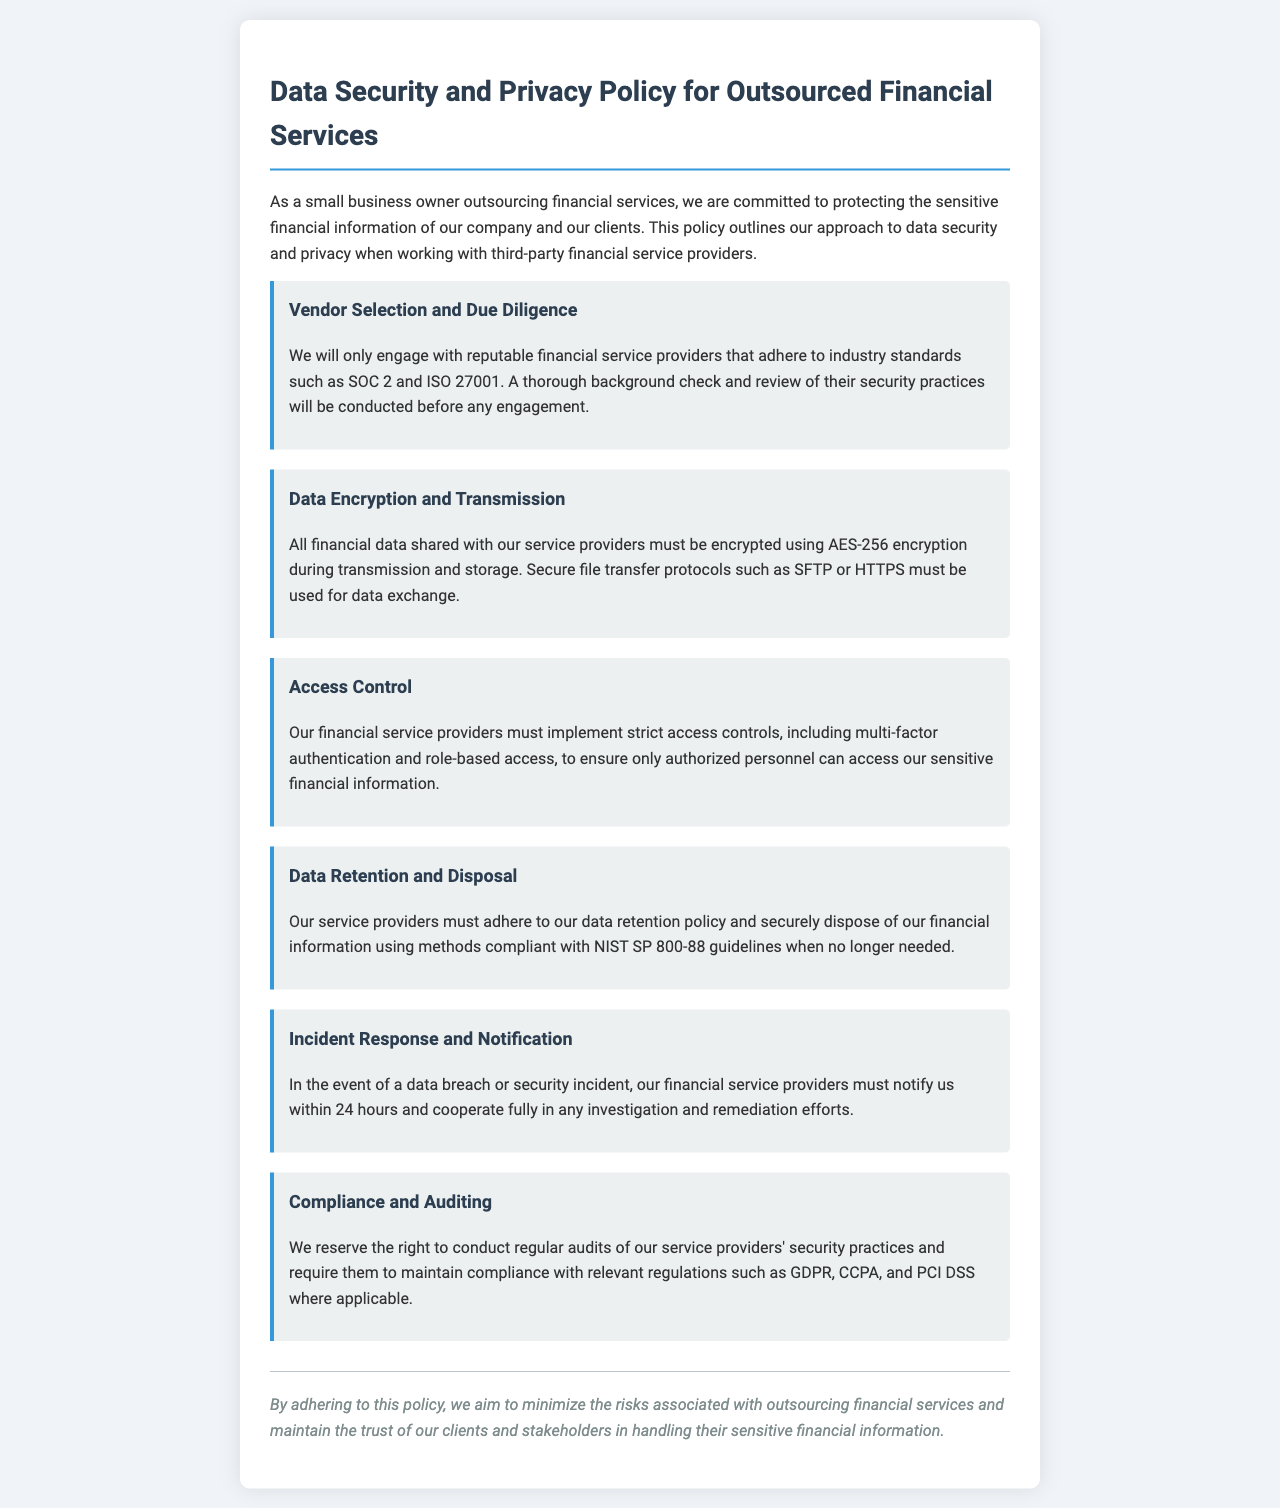What standards must vendors adhere to? The policy states that vendors must adhere to industry standards such as SOC 2 and ISO 27001.
Answer: SOC 2 and ISO 27001 What encryption method is required for financial data? The document specifies that all financial data must be encrypted using AES-256 encryption.
Answer: AES-256 What access controls must service providers implement? The policy requires service providers to implement strict access controls including multi-factor authentication and role-based access.
Answer: Multi-factor authentication and role-based access How soon must vendors notify us of a data breach? In the event of a data breach, vendors are required to notify us within 24 hours.
Answer: 24 hours Which guidelines must be followed for data disposal? The policy states that secure disposal must be compliant with NIST SP 800-88 guidelines.
Answer: NIST SP 800-88 What is the purpose of regular audits? Regular audits are conducted to ensure compliance with relevant regulations and to review security practices.
Answer: Compliance with relevant regulations What is the main goal of the policy? The main goal is to minimize risks associated with outsourcing financial services and to maintain trust with clients.
Answer: Minimize risks and maintain trust What must be done with data no longer needed? The document outlines that data no longer needed must be securely disposed of according to specific guidelines.
Answer: Securely disposed of What regulations must service providers comply with? Service providers must maintain compliance with regulations such as GDPR, CCPA, and PCI DSS where applicable.
Answer: GDPR, CCPA, PCI DSS 